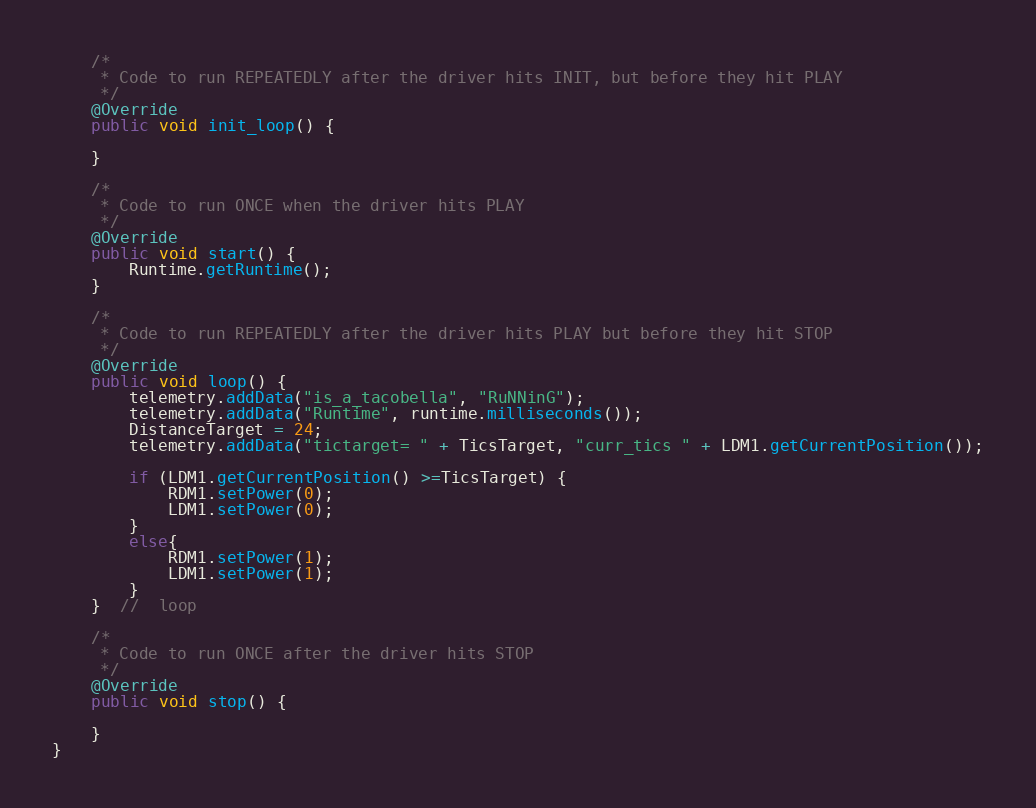<code> <loc_0><loc_0><loc_500><loc_500><_Java_>    /*
     * Code to run REPEATEDLY after the driver hits INIT, but before they hit PLAY
     */
    @Override
    public void init_loop() {

    }

    /*
     * Code to run ONCE when the driver hits PLAY
     */
    @Override
    public void start() {
        Runtime.getRuntime();
    }

    /*
     * Code to run REPEATEDLY after the driver hits PLAY but before they hit STOP
     */
    @Override
    public void loop() {
        telemetry.addData("is_a_tacobella", "RuNNinG");
        telemetry.addData("Runtime", runtime.milliseconds());
        DistanceTarget = 24;
        telemetry.addData("tictarget= " + TicsTarget, "curr_tics " + LDM1.getCurrentPosition());

        if (LDM1.getCurrentPosition() >=TicsTarget) {
            RDM1.setPower(0);
            LDM1.setPower(0);
        }
        else{
            RDM1.setPower(1);
            LDM1.setPower(1);
        }
    }  //  loop

    /*
     * Code to run ONCE after the driver hits STOP
     */
    @Override
    public void stop() {

    }
}
</code> 